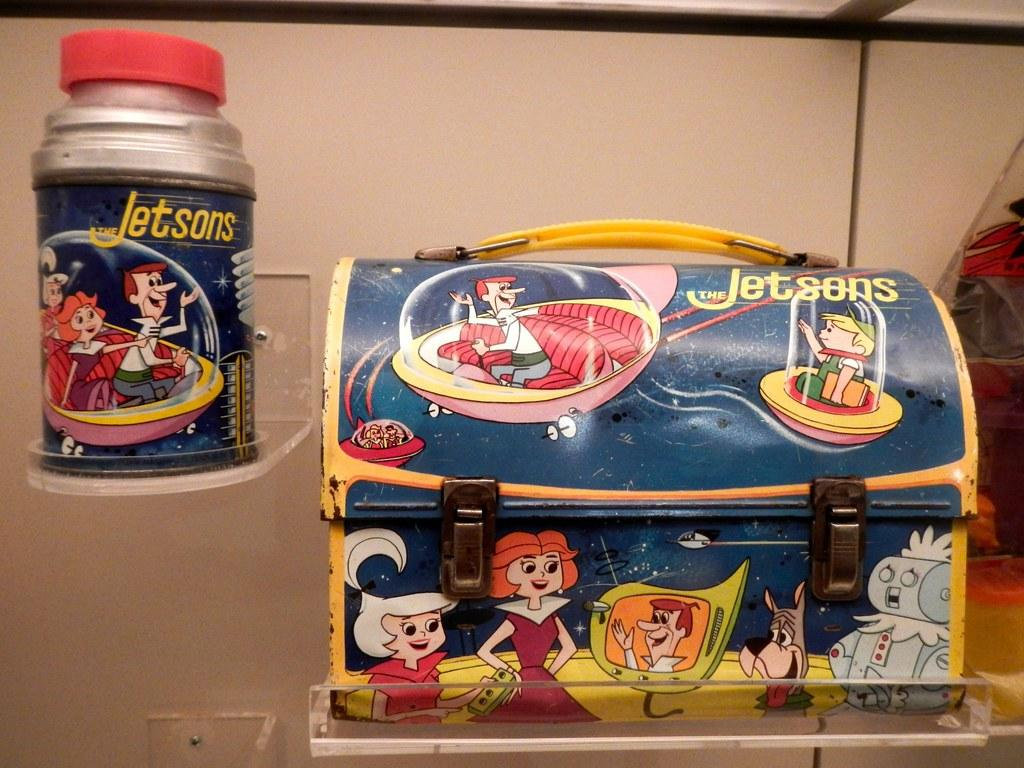What type of object is in the image? There is a metal box in the image. Can you describe another object near the metal box? There is a metal bottle beside the metal box in the image. What type of bread can be seen floating on the lake in the image? There is no bread or lake present in the image; it only features a metal box and a metal bottle. 